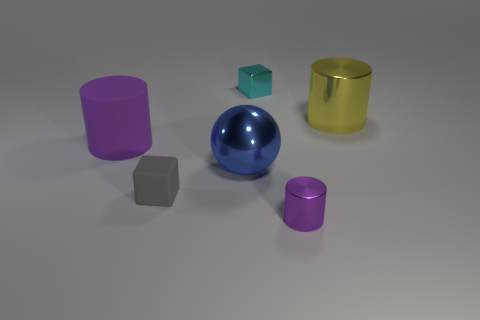Do the cyan block and the purple cylinder right of the small gray rubber object have the same material?
Provide a succinct answer. Yes. How many objects are tiny shiny cubes or big brown matte blocks?
Give a very brief answer. 1. There is another cylinder that is the same color as the small cylinder; what is it made of?
Provide a short and direct response. Rubber. Is there another large metal object of the same shape as the gray object?
Make the answer very short. No. What number of small gray rubber things are behind the gray object?
Your response must be concise. 0. What is the tiny block in front of the big cylinder on the left side of the yellow object made of?
Your answer should be compact. Rubber. There is a cyan thing that is the same size as the gray rubber block; what is its material?
Make the answer very short. Metal. Is there another purple cylinder that has the same size as the purple matte cylinder?
Your answer should be very brief. No. There is a metal cylinder in front of the small rubber thing; what is its color?
Offer a terse response. Purple. There is a metal object that is on the left side of the cyan cube; is there a big purple thing to the right of it?
Offer a terse response. No. 